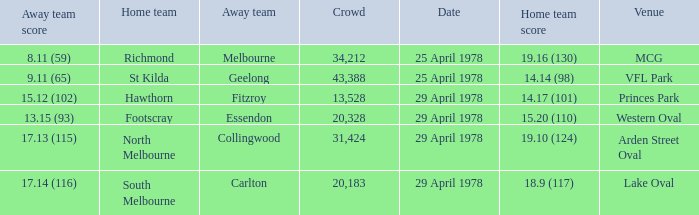What was the away team that played at Princes Park? Fitzroy. 